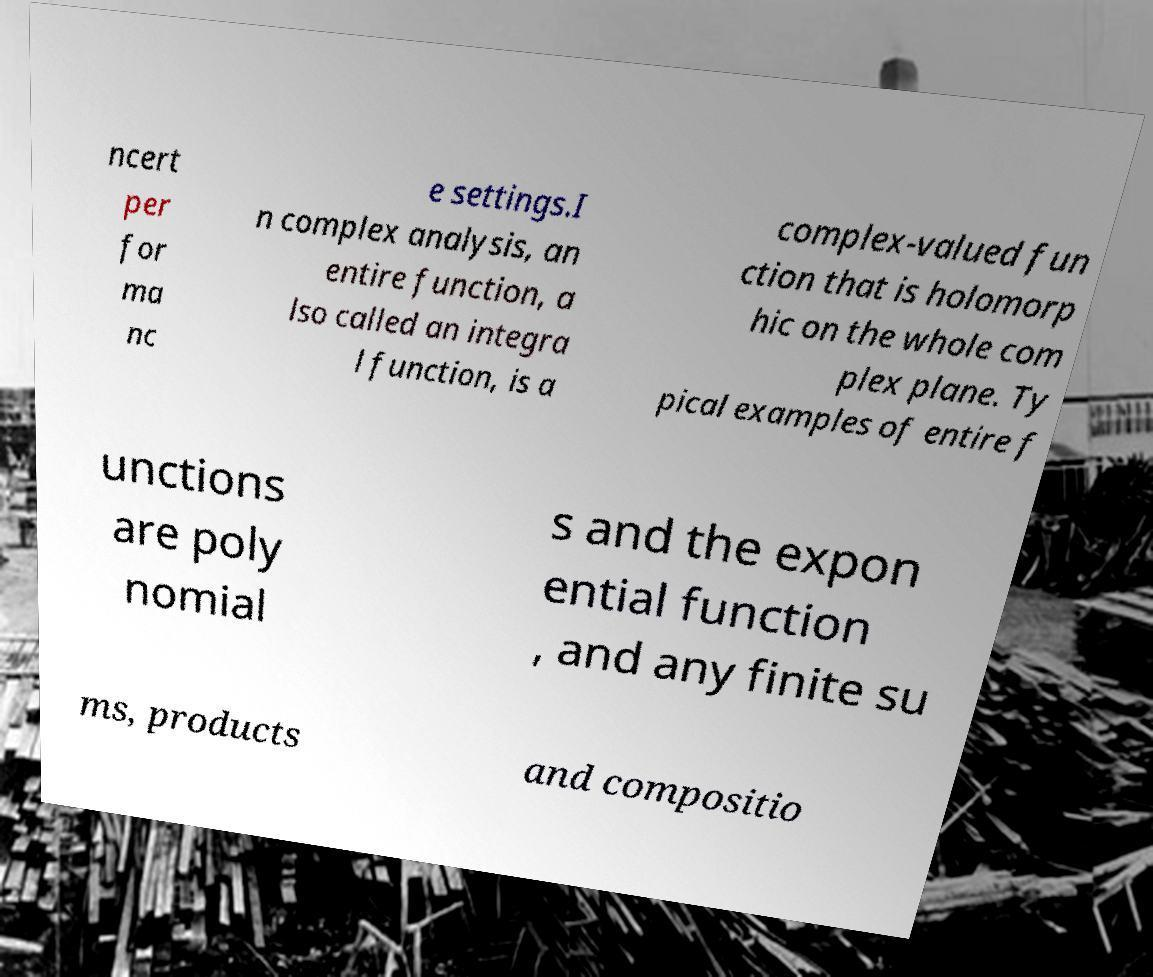Could you extract and type out the text from this image? ncert per for ma nc e settings.I n complex analysis, an entire function, a lso called an integra l function, is a complex-valued fun ction that is holomorp hic on the whole com plex plane. Ty pical examples of entire f unctions are poly nomial s and the expon ential function , and any finite su ms, products and compositio 